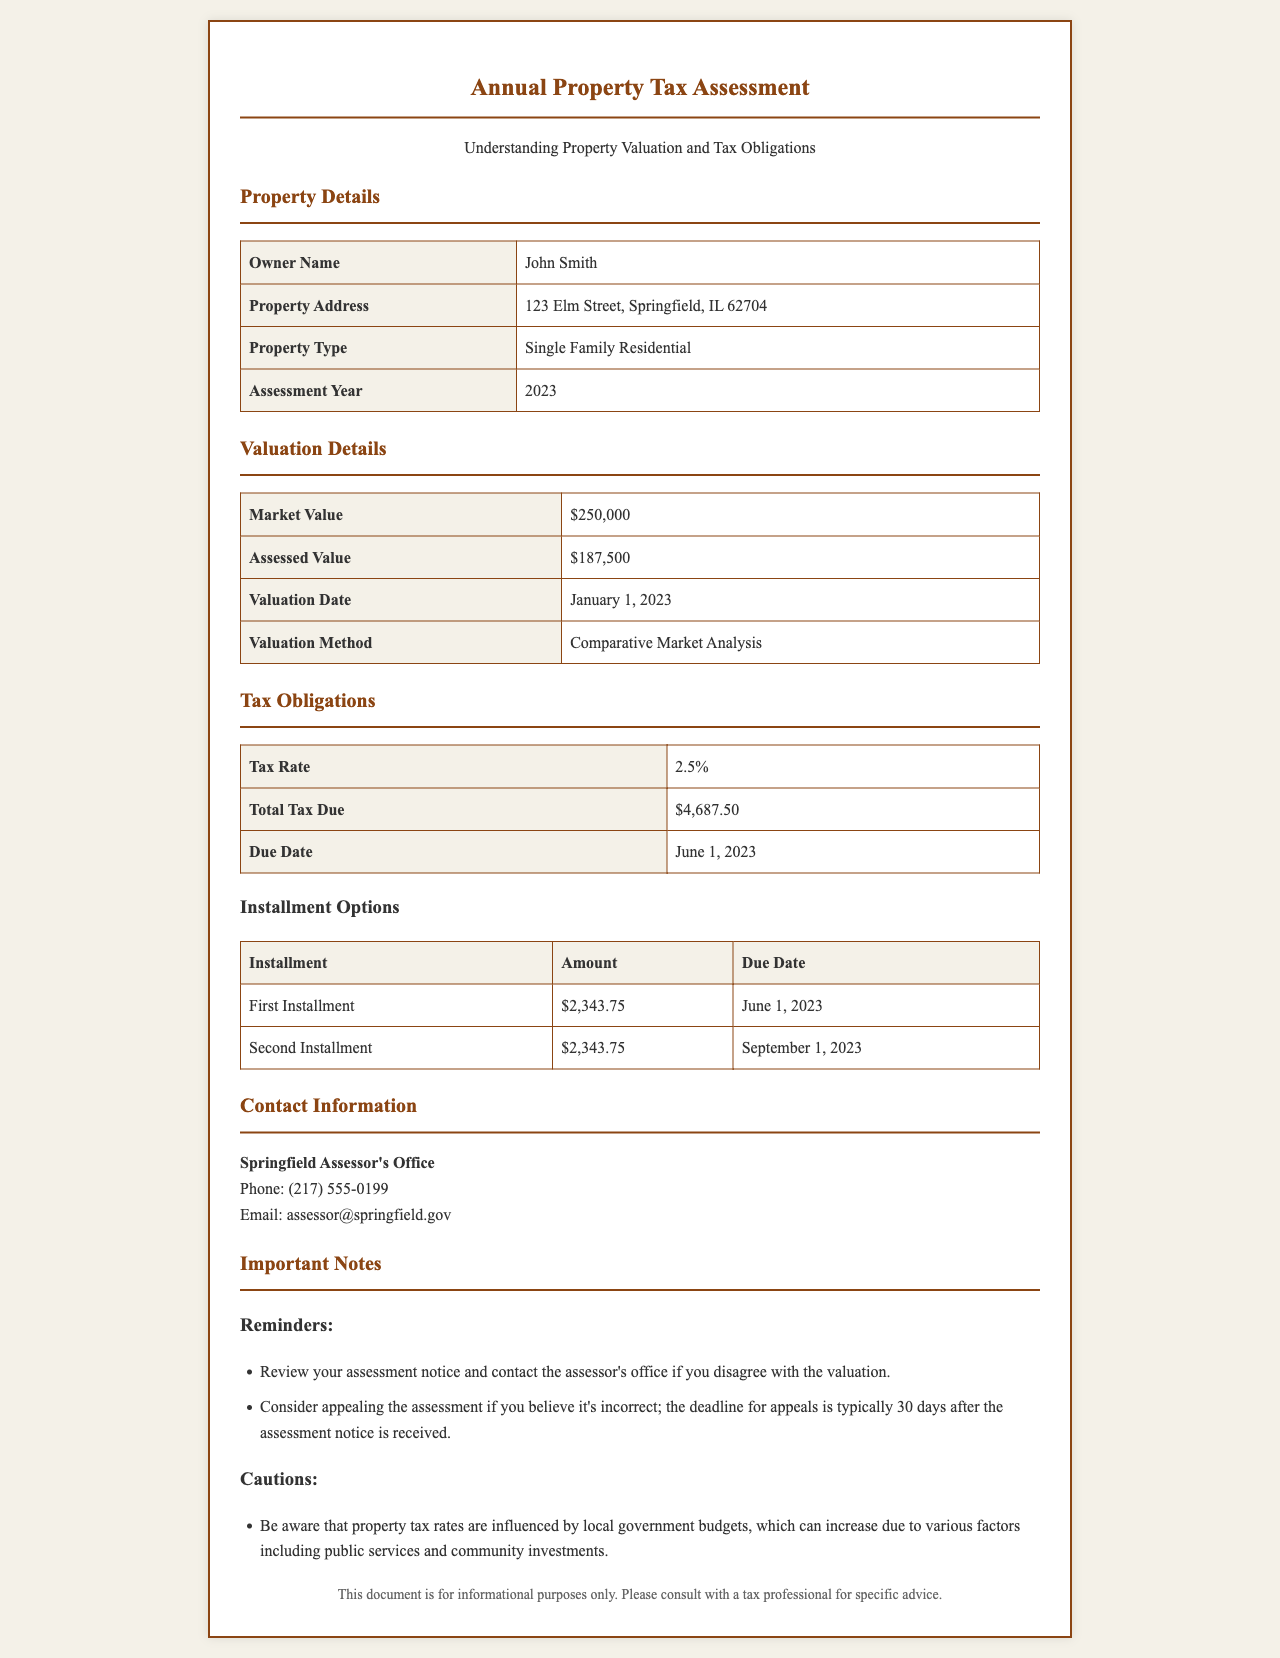What is the owner's name? The owner's name is provided in the property details section of the document as John Smith.
Answer: John Smith What is the property address? The property address is given in the document and includes the street, city, state, and zip code as 123 Elm Street, Springfield, IL 62704.
Answer: 123 Elm Street, Springfield, IL 62704 What is the assessed value of the property? The assessed value is found in the valuation details section, which indicates the property is assessed at $187,500.
Answer: $187,500 What is the total tax due? The total tax due is found in the tax obligations section and is specified as $4,687.50.
Answer: $4,687.50 What are the due dates for the installments? The due dates for the installments are listed in the tax obligations section as June 1, 2023, and September 1, 2023.
Answer: June 1, 2023 and September 1, 2023 What is the tax rate? The tax rate is stated in the document in the tax obligations section as 2.5%.
Answer: 2.5% What is the valuation date? The valuation date is found in the valuation details section and is specified as January 1, 2023.
Answer: January 1, 2023 What should you do if you disagree with the assessment? The document advises that you should review your assessment notice and contact the assessor's office if you disagree with the valuation.
Answer: Contact the assessor's office What is the contact phone number for the Springfield Assessor's Office? The contact phone number is provided in the contact information section as (217) 555-0199.
Answer: (217) 555-0199 